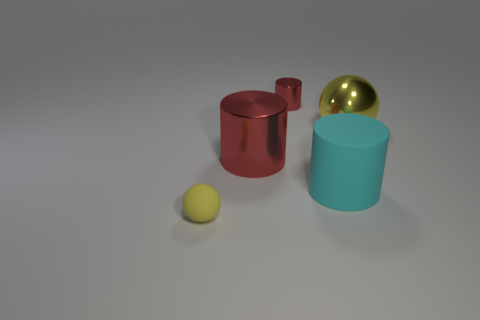There is a red object that is the same size as the cyan rubber object; what shape is it?
Your answer should be compact. Cylinder. Are there any other small shiny things that have the same shape as the yellow shiny thing?
Provide a succinct answer. No. Is the tiny yellow ball made of the same material as the yellow sphere that is to the right of the tiny yellow rubber sphere?
Make the answer very short. No. What is the color of the tiny thing in front of the sphere that is right of the yellow sphere that is in front of the large cyan rubber cylinder?
Provide a short and direct response. Yellow. There is a red thing that is the same size as the yellow rubber object; what material is it?
Make the answer very short. Metal. How many cyan things have the same material as the big sphere?
Your answer should be compact. 0. Do the red metal thing behind the big yellow ball and the shiny cylinder that is in front of the small red cylinder have the same size?
Keep it short and to the point. No. What color is the big metal thing on the right side of the big cyan matte cylinder?
Make the answer very short. Yellow. There is a small ball that is the same color as the big ball; what is it made of?
Provide a short and direct response. Rubber. How many big shiny spheres are the same color as the small metal cylinder?
Provide a short and direct response. 0. 